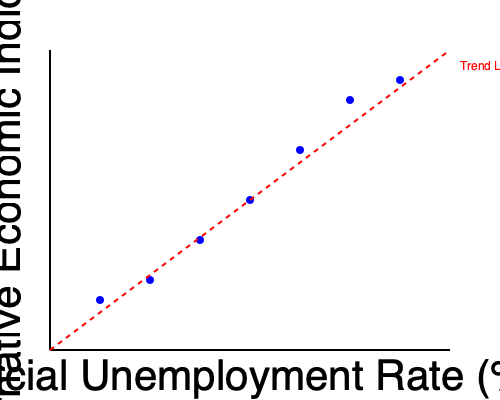Based on the scatter plot comparing official unemployment rates with an alternative economic indicator, what discrepancy does this data suggest about the government's reporting of unemployment figures? To answer this question, we need to analyze the scatter plot and its implications:

1. The x-axis represents the official unemployment rate, while the y-axis represents an alternative economic indicator.

2. The blue dots show a clear negative correlation between the two variables: as the official unemployment rate increases, the alternative economic indicator decreases.

3. The red dashed line represents the trend line, which emphasizes this negative correlation.

4. In a perfectly transparent reporting system, we would expect the official unemployment rate and the alternative economic indicator to move in the same direction (positive correlation).

5. The negative correlation suggests that as the government reports lower unemployment rates, the alternative economic indicator shows a worsening economic situation.

6. This discrepancy implies that the official unemployment figures may not be capturing the full extent of economic hardship or underemployment in the population.

7. The alternative economic indicator could be measuring factors like underemployment, discouraged workers, or other economic stress indicators not reflected in the official unemployment rate.

8. The consistent pattern across different unemployment rates suggests this is not a random occurrence but a systematic difference between official figures and alternative measures.

Given the persona of a skeptical local journalist, this data would raise questions about the accuracy and comprehensiveness of official unemployment reports, suggesting potential underreporting or use of narrow definitions that may not reflect the true economic situation.
Answer: Potential underreporting of true unemployment/economic hardship in official figures 